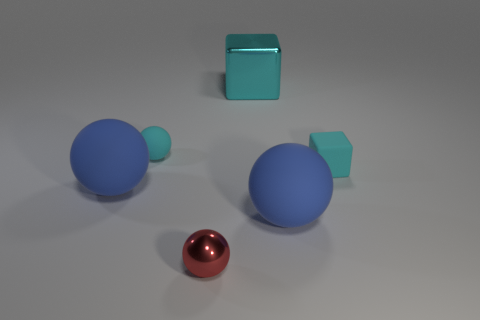Is there another thing that has the same color as the small metal object?
Offer a very short reply. No. What color is the rubber cube that is the same size as the red sphere?
Your response must be concise. Cyan. Is the color of the big matte object that is right of the tiny shiny object the same as the rubber block?
Offer a terse response. No. Is there a cyan ball that has the same material as the red object?
Give a very brief answer. No. There is a shiny thing that is the same color as the small rubber cube; what is its shape?
Provide a succinct answer. Cube. Are there fewer large cyan metal objects that are on the right side of the small red metallic object than tiny cyan rubber spheres?
Ensure brevity in your answer.  No. Does the block that is on the right side of the metal block have the same size as the tiny red thing?
Keep it short and to the point. Yes. How many blue rubber things have the same shape as the small metal object?
Provide a short and direct response. 2. There is a cyan sphere that is made of the same material as the tiny cyan cube; what is its size?
Ensure brevity in your answer.  Small. Is the number of cyan rubber things left of the small cyan matte block the same as the number of small rubber balls?
Make the answer very short. Yes. 